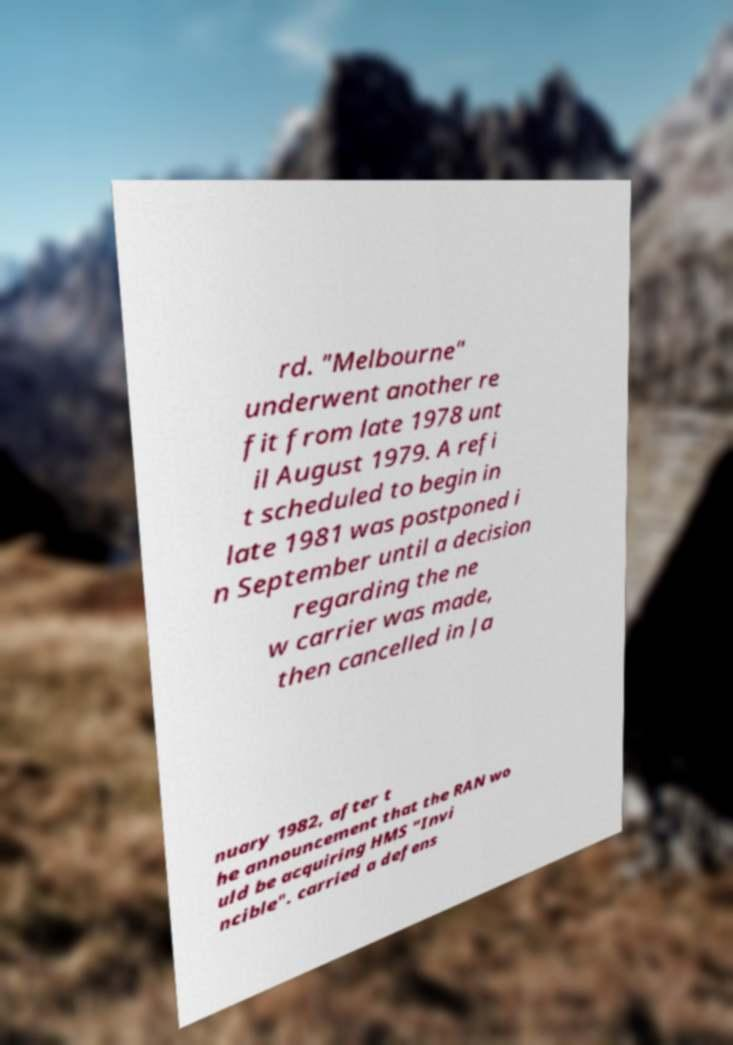There's text embedded in this image that I need extracted. Can you transcribe it verbatim? rd. "Melbourne" underwent another re fit from late 1978 unt il August 1979. A refi t scheduled to begin in late 1981 was postponed i n September until a decision regarding the ne w carrier was made, then cancelled in Ja nuary 1982, after t he announcement that the RAN wo uld be acquiring HMS "Invi ncible". carried a defens 